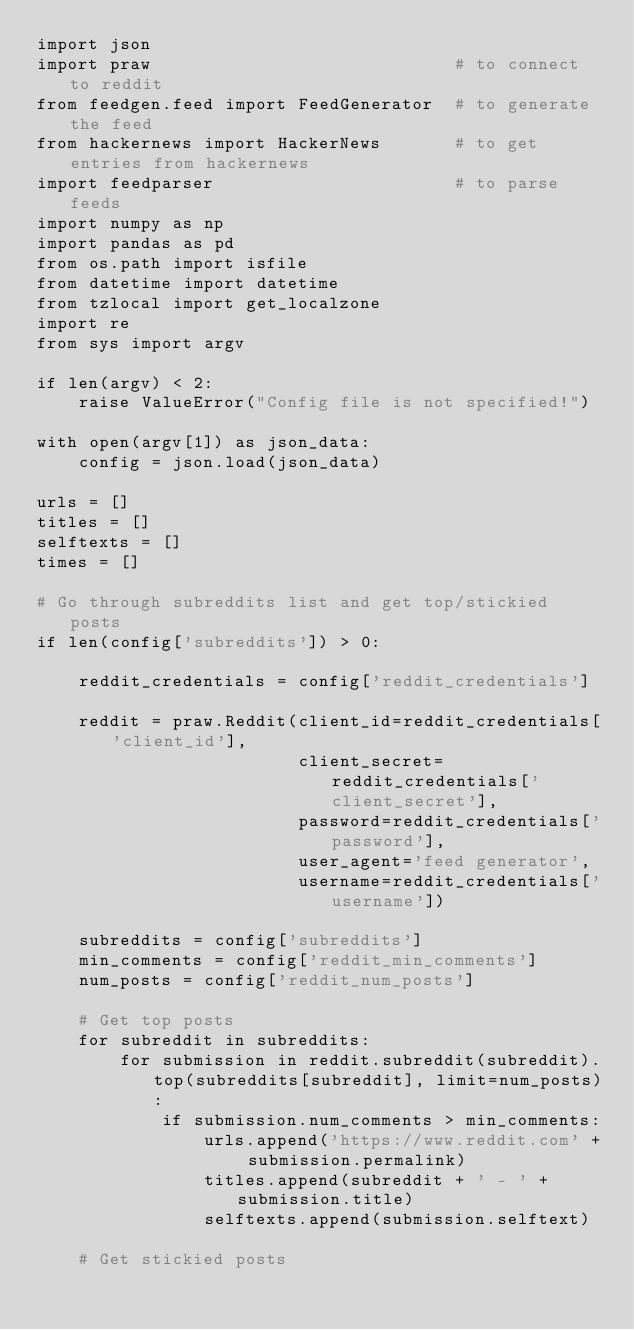Convert code to text. <code><loc_0><loc_0><loc_500><loc_500><_Python_>import json
import praw                             # to connect to reddit
from feedgen.feed import FeedGenerator  # to generate the feed
from hackernews import HackerNews       # to get entries from hackernews
import feedparser                       # to parse feeds
import numpy as np
import pandas as pd
from os.path import isfile
from datetime import datetime
from tzlocal import get_localzone
import re
from sys import argv

if len(argv) < 2:
    raise ValueError("Config file is not specified!")

with open(argv[1]) as json_data:
    config = json.load(json_data)

urls = []
titles = []
selftexts = []
times = []

# Go through subreddits list and get top/stickied posts
if len(config['subreddits']) > 0:

    reddit_credentials = config['reddit_credentials']

    reddit = praw.Reddit(client_id=reddit_credentials['client_id'],
                         client_secret=reddit_credentials['client_secret'],
                         password=reddit_credentials['password'],
                         user_agent='feed generator',
                         username=reddit_credentials['username'])

    subreddits = config['subreddits']
    min_comments = config['reddit_min_comments']
    num_posts = config['reddit_num_posts']

    # Get top posts
    for subreddit in subreddits:
        for submission in reddit.subreddit(subreddit).top(subreddits[subreddit], limit=num_posts):
            if submission.num_comments > min_comments:
                urls.append('https://www.reddit.com' + submission.permalink)
                titles.append(subreddit + ' - ' + submission.title)
                selftexts.append(submission.selftext)

    # Get stickied posts</code> 